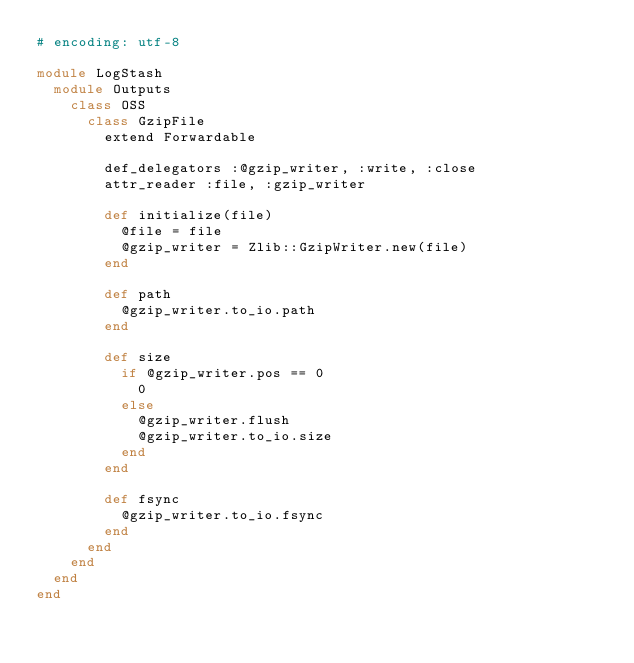Convert code to text. <code><loc_0><loc_0><loc_500><loc_500><_Ruby_># encoding: utf-8

module LogStash
  module Outputs
    class OSS
      class GzipFile
        extend Forwardable

        def_delegators :@gzip_writer, :write, :close
        attr_reader :file, :gzip_writer

        def initialize(file)
          @file = file
          @gzip_writer = Zlib::GzipWriter.new(file)
        end

        def path
          @gzip_writer.to_io.path
        end

        def size
          if @gzip_writer.pos == 0
            0
          else
            @gzip_writer.flush
            @gzip_writer.to_io.size
          end
        end

        def fsync
          @gzip_writer.to_io.fsync
        end
      end
    end
  end
end
</code> 